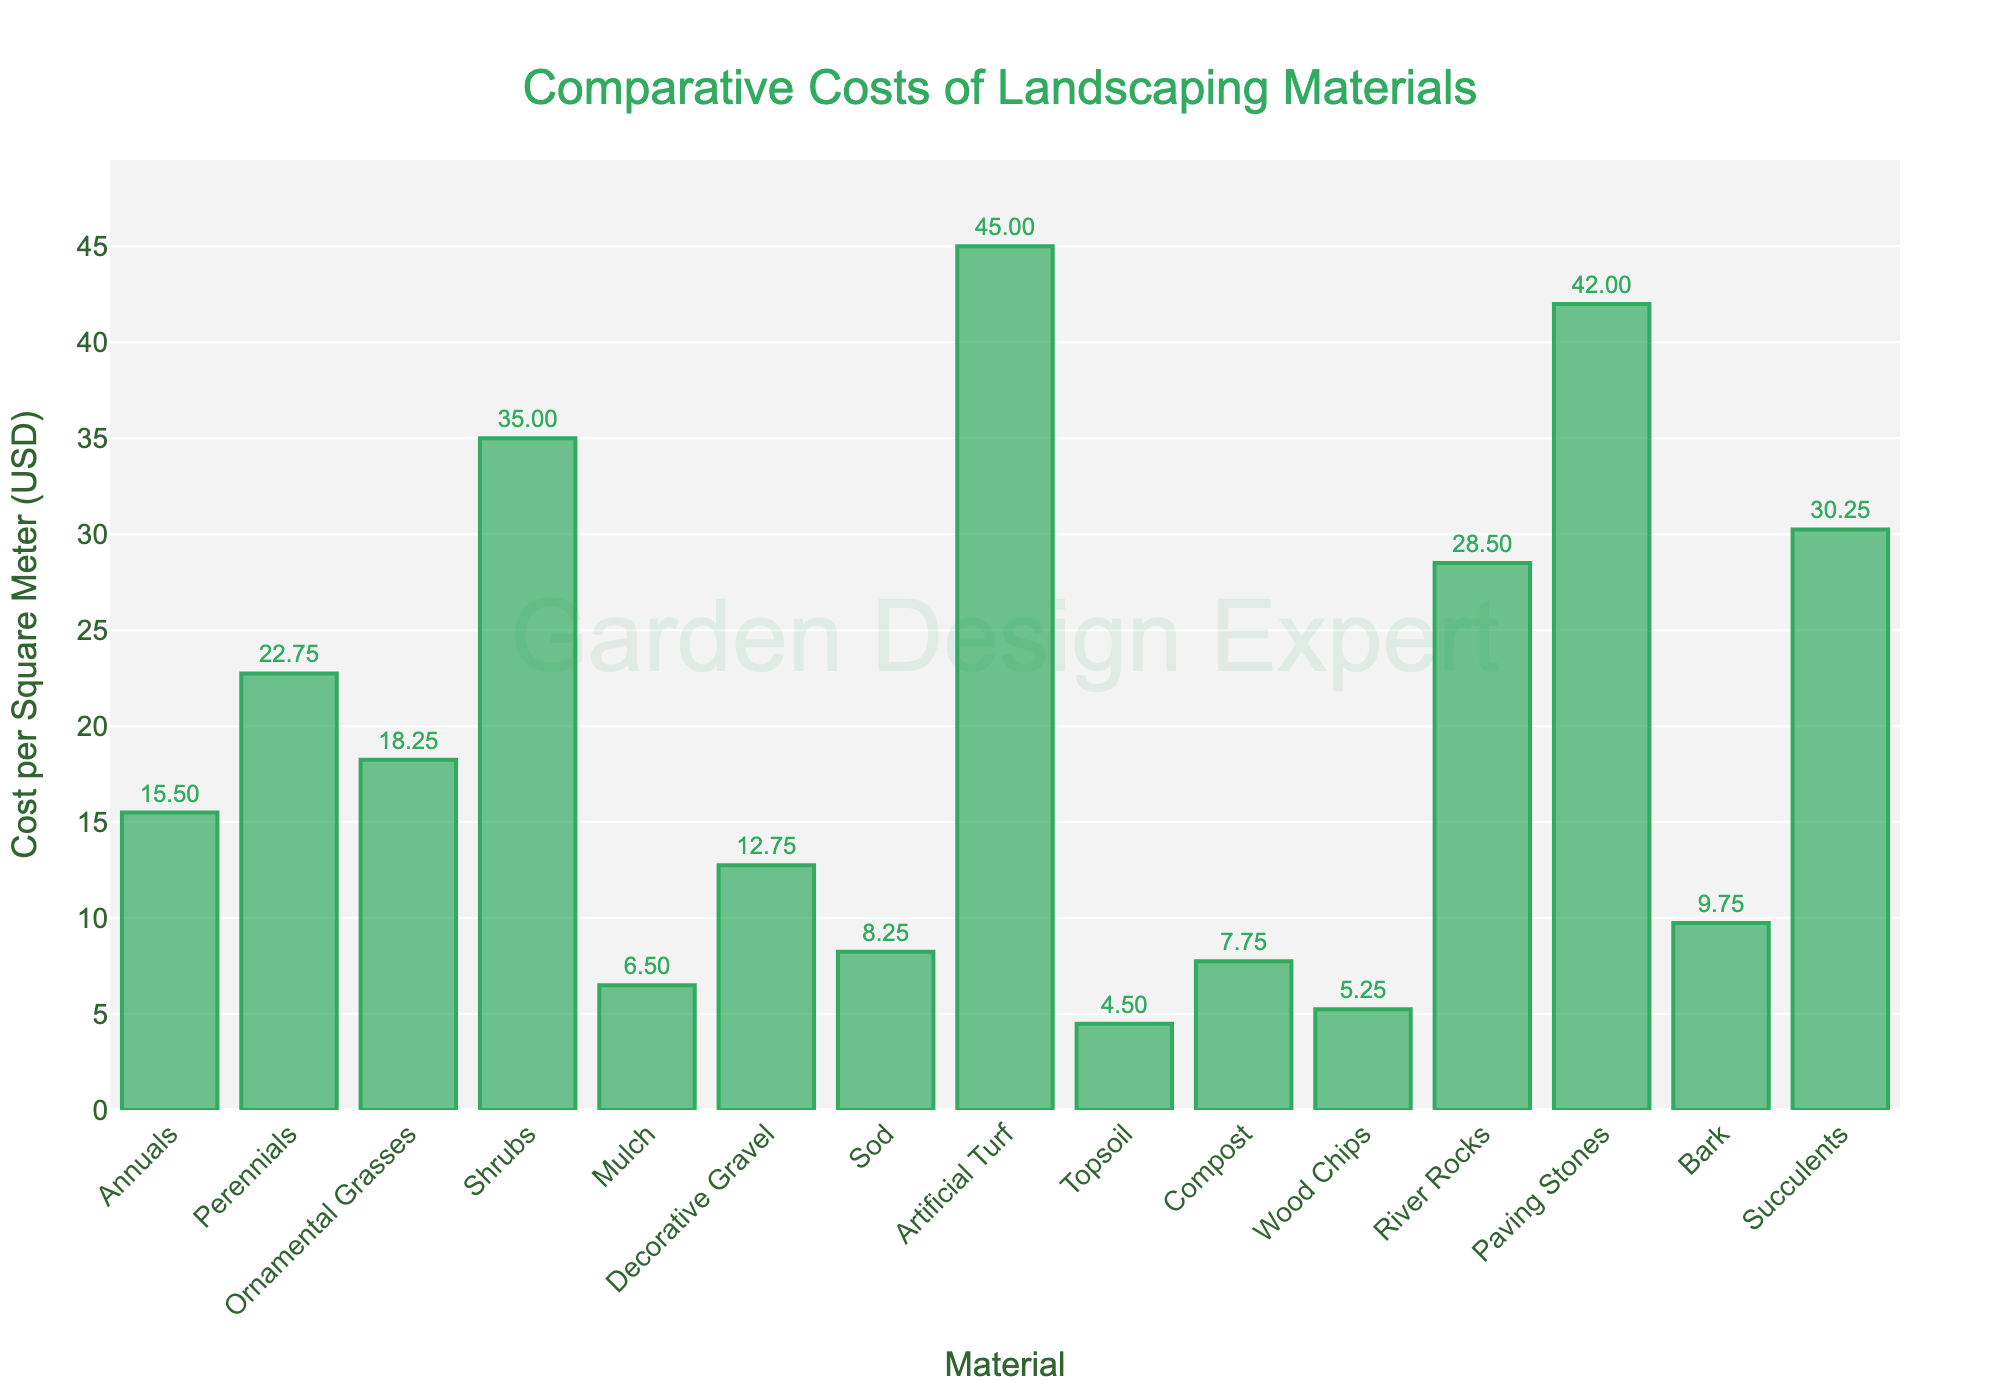Which material has the highest cost per square meter? The bar representing Artificial Turf is the tallest among all the bars in the figure, indicating that it has the highest cost per square meter.
Answer: Artificial Turf What is the difference in cost per square meter between Perennials and Sod? Perennials cost 22.75 USD per square meter and Sod costs 8.25 USD per square meter. The difference is calculated as 22.75 - 8.25.
Answer: 14.50 How many materials have a cost per square meter greater than 25 USD? By examining the height of the bars, we can see that Shrubs, Artificial Turf, River Rocks, Paving Stones, and Succulents have costs per square meter exceeding 25 USD.
Answer: 5 Which is less expensive per square meter, Decorative Gravel or Bark? The bar for Decorative Gravel is lower than the bar for Bark. Decorative Gravel costs 12.75 USD per square meter, while Bark costs 9.75 USD per square meter.
Answer: Bark What's the combined cost per square meter of Mulch, Topsoil, and Wood Chips? Mulch costs 6.50 USD per square meter, Topsoil costs 4.50 USD per square meter, and Wood Chips cost 5.25 USD per square meter. The combined cost is calculated as 6.50 + 4.50 + 5.25.
Answer: 16.25 What is the average cost per square meter for Annuals, Perennials, and Succulents? Annuals cost 15.50 USD per square meter, Perennials cost 22.75 USD per square meter, and Succulents cost 30.25 USD per square meter. The average cost is calculated as (15.50 + 22.75 + 30.25) / 3.
Answer: 22.83 Which material is depicted by the bar that is closest in height to the one representing Ornamental Grasses? Decorative Gravel has a bar height that is closest to Ornamental Grasses. Ornamental Grasses cost 18.25 USD per square meter, and Decorative Gravel costs 12.75 USD per square meter.
Answer: Decorative Gravel Are there more materials with a cost per square meter less than 10 USD or more than 30 USD? By counting the number of bars, materials with cost less than 10 USD include Mulch, Sod, Topsoil, Compost, and Wood Chips (5 materials). Materials with cost more than 30 USD include Shrubs, Artificial Turf, River Rocks, Paving Stones, and Succulents (5 materials).
Answer: Equal What is the median cost per square meter among all materials? First, order all costs per square meter: 4.50, 5.25, 6.50, 7.75, 8.25, 9.75, 12.75, 15.50, 18.25, 22.75, 28.50, 30.25, 35.00, 42.00, 45.00. The middle value (8th in a list of 15) is 15.50.
Answer: 15.50 Which material's cost per square meter is closest to the average cost per square meter of all listed materials? Sum all costs per square meter: 4.50 + 5.25 + 6.50 + 7.75 + 8.25 + 9.75 + 12.75 + 15.50 + 18.25 + 22.75 + 28.50 + 30.25 + 35.00 + 42.00 + 45.00 = 292.00. The average is 292.00 / 15 = 19.47 USD. Ornamental Grasses cost 18.25 USD per square meter, which is closest to this average.
Answer: Ornamental Grasses 